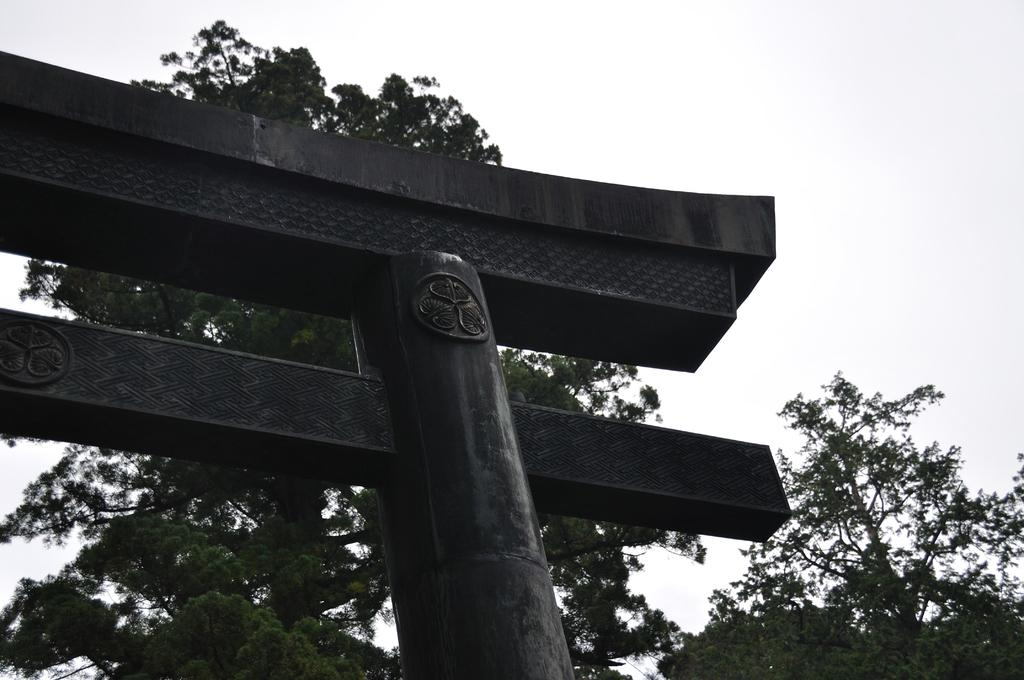What type of structure is present in the image? There is an arch in the image. What can be seen in the background of the image? There is sky and trees visible in the background of the image. How many legs can be seen supporting the arch in the image? There are no legs visible in the image; the arch is likely supported by other structural elements that are not shown. 